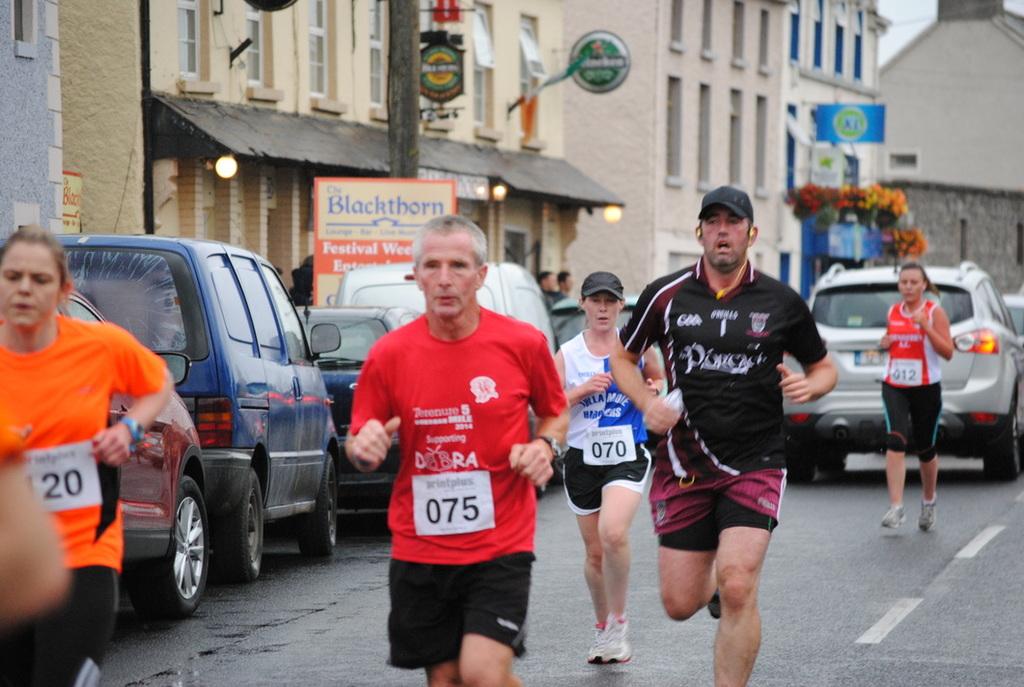What are the runners' numbers?
Make the answer very short. 20, 075, 070, 012. What is name of the building to the left?
Offer a terse response. Blackthorn. 